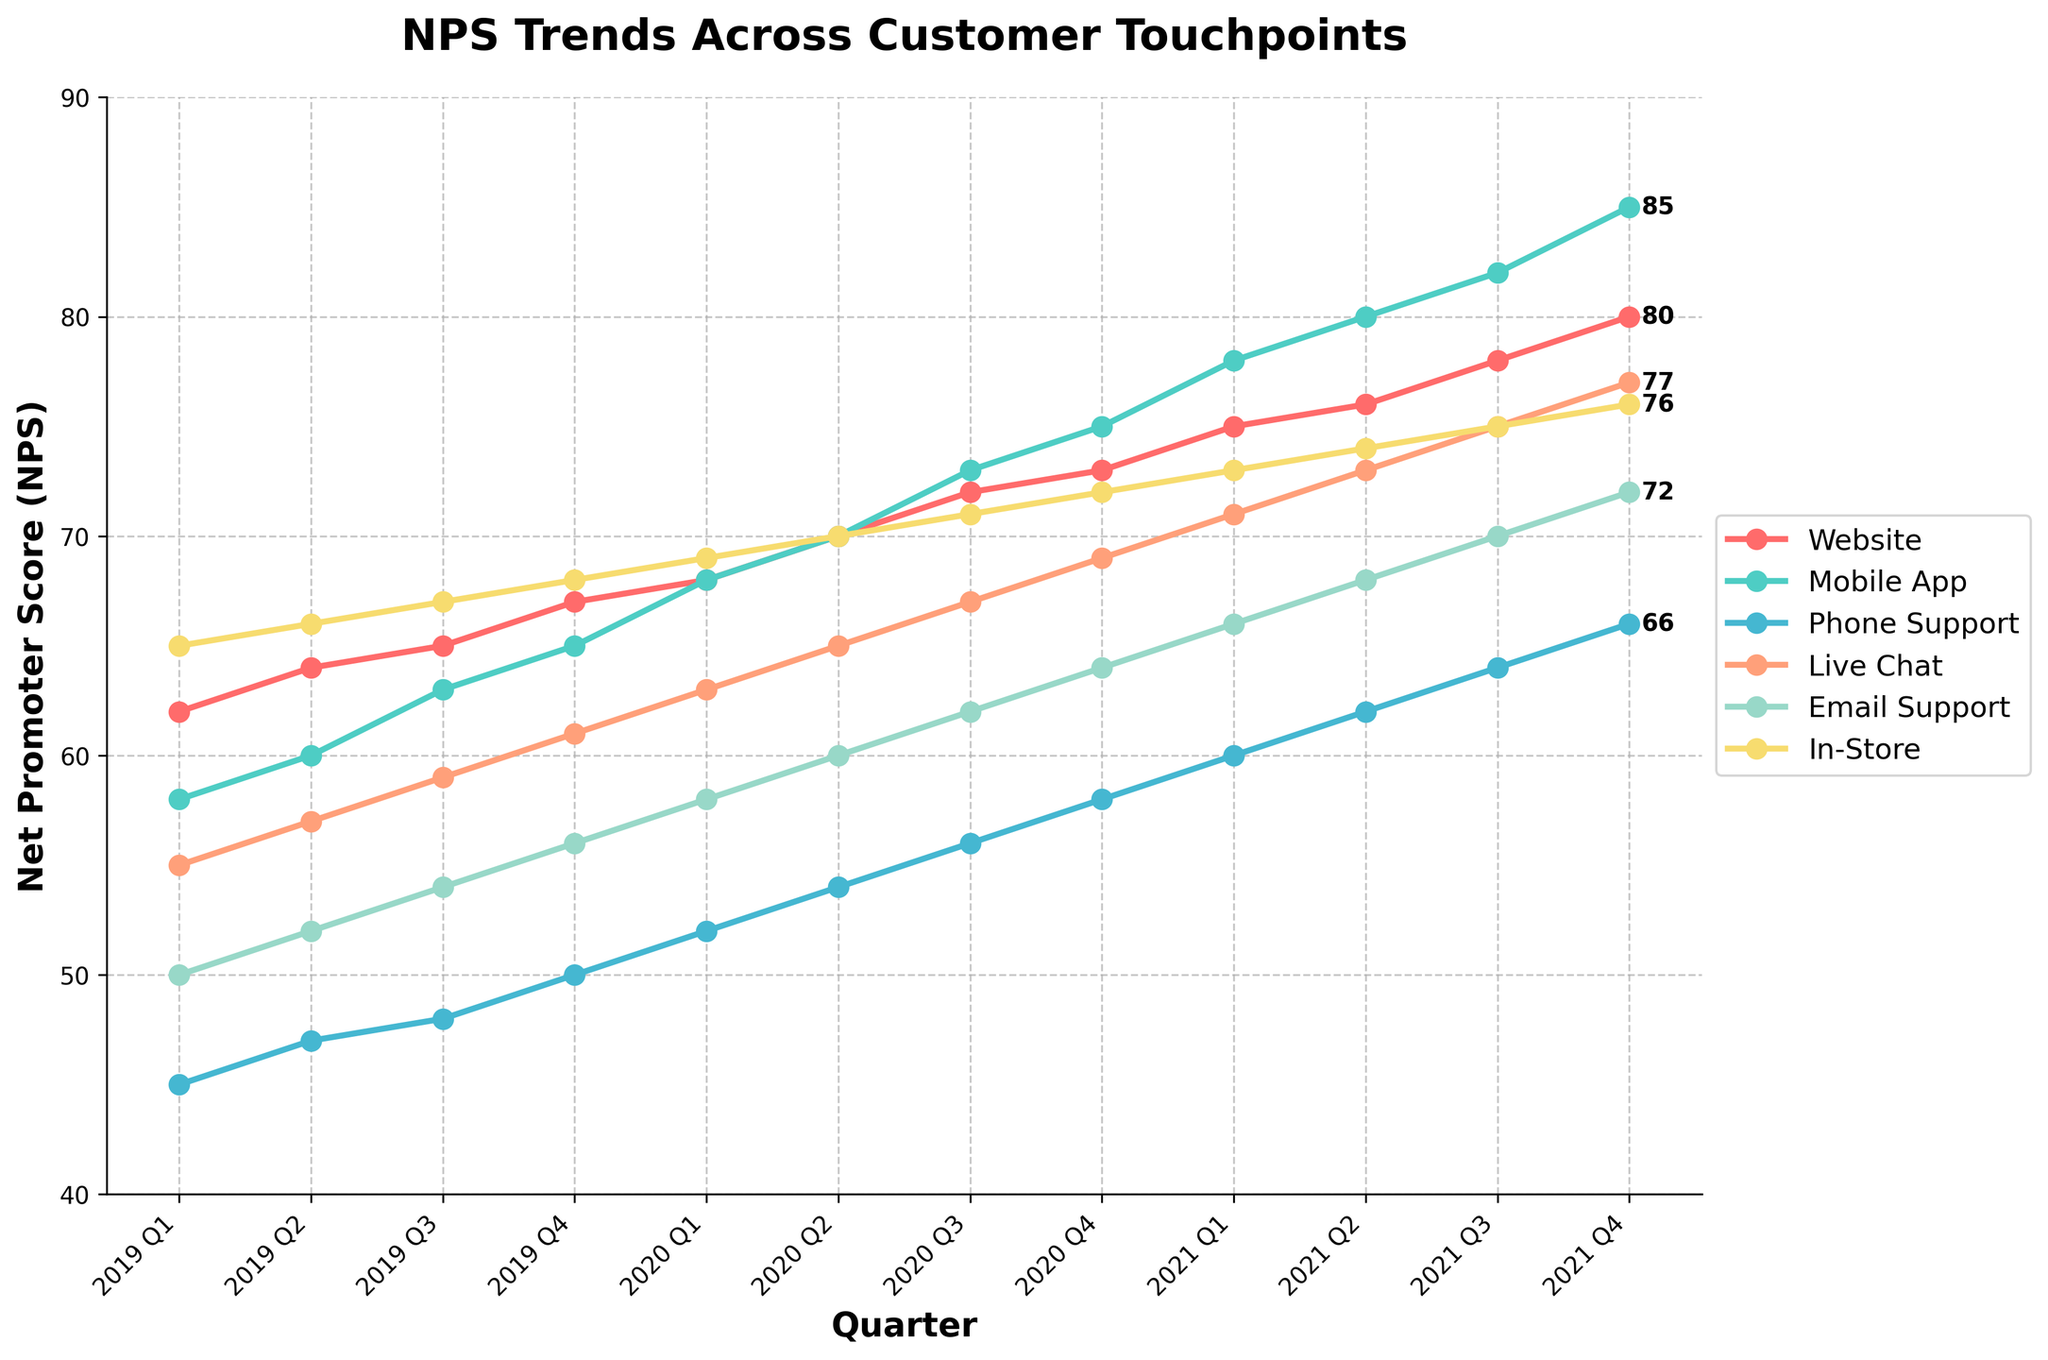Which touchpoint had the highest NPS in 2021 Q4? Look for the highest data point in the 2021 Q4 section. The mobile app has the highest NPS score at this touchpoint.
Answer: Mobile App Which years show the most significant increase in NPS across all touchpoints? Identify the periods with the steepest slopes. The most significant increases appear between 2019 and 2021, particularly noticeable for Mobile App and Phone Support.
Answer: 2019-2021 How does the NPS trend of Phone Support compare to Email Support? Compare the slopes and values of the lines representing Phone Support and Email Support over time. Both have positive trends, but Phone Support started and ended with lower scores compared to Email Support.
Answer: Similar trends, Phone Support lower What is the overall average NPS for the Website touchpoint across all quarters? Sum all NPS values for the Website touchpoint and divide by the number of quarters: (62+64+65+67+68+70+72+73+75+76+78+80)/12.
Answer: 70.8 Which touchpoint experienced the least change in NPS from 2019 Q1 to 2021 Q4? Calculate the difference from 2019 Q1 to 2021 Q4 for each touchpoint. The In-Store touchpoint has the smallest difference (76-65 = 11).
Answer: In-Store What is the difference in NPS between the Mobile App and In-Store touchpoints in 2021 Q4? Subtract the NPS for In-Store from Mobile App for 2021 Q4: 85 - 76.
Answer: 9 Which quarter did the Live Chat touchpoint see the highest increase in NPS? Look for the quarter-to-quarter change that is the largest for Live Chat. The highest increase is from 2020 Q2 to 2020 Q3 (65 to 67).
Answer: 2020 Q2 to 2020 Q3 How do the trends of the Mobile App and Website touchpoints compare over the observed period? Compare the slopes and NPS values over time. Both touchpoints show a positive trend, with the Mobile App having a steeper increase and higher final value.
Answer: Mobile App steeper and higher What is the average NPS increase per year for Email Support? Calculate the total increase (72 - 50 = 22) and divide by the number of years (22/3 = 7.33).
Answer: 7.33 In which quarter did the Phone Support touchpoint first surpass an NPS of 50? Look for the first occurrence where Phone Support's NPS is above 50. This happened in 2020 Q1.
Answer: 2020 Q1 